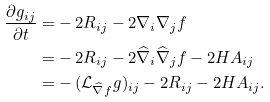Convert formula to latex. <formula><loc_0><loc_0><loc_500><loc_500>\frac { \partial g _ { i j } } { \partial t } = & - 2 R _ { i j } - 2 \nabla _ { i } \nabla _ { j } f \\ = & - 2 R _ { i j } - 2 \widehat { \nabla } _ { i } \widehat { \nabla } _ { j } f - 2 H A _ { i j } \\ = & - ( { \mathcal { L } } _ { \widehat { \nabla } f } g ) _ { i j } - 2 R _ { i j } - 2 H A _ { i j } .</formula> 